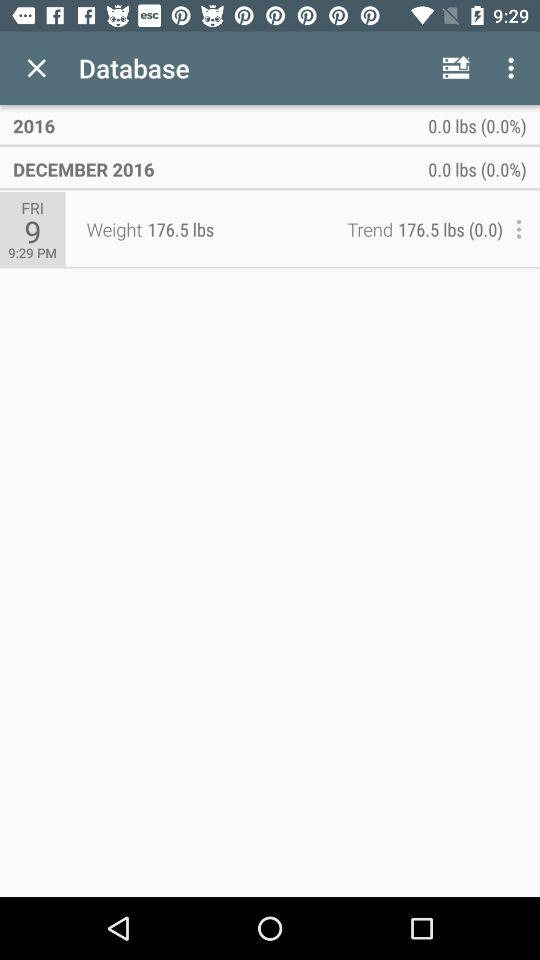What is the measured weight? The measured weight is 176.5 lbs. 